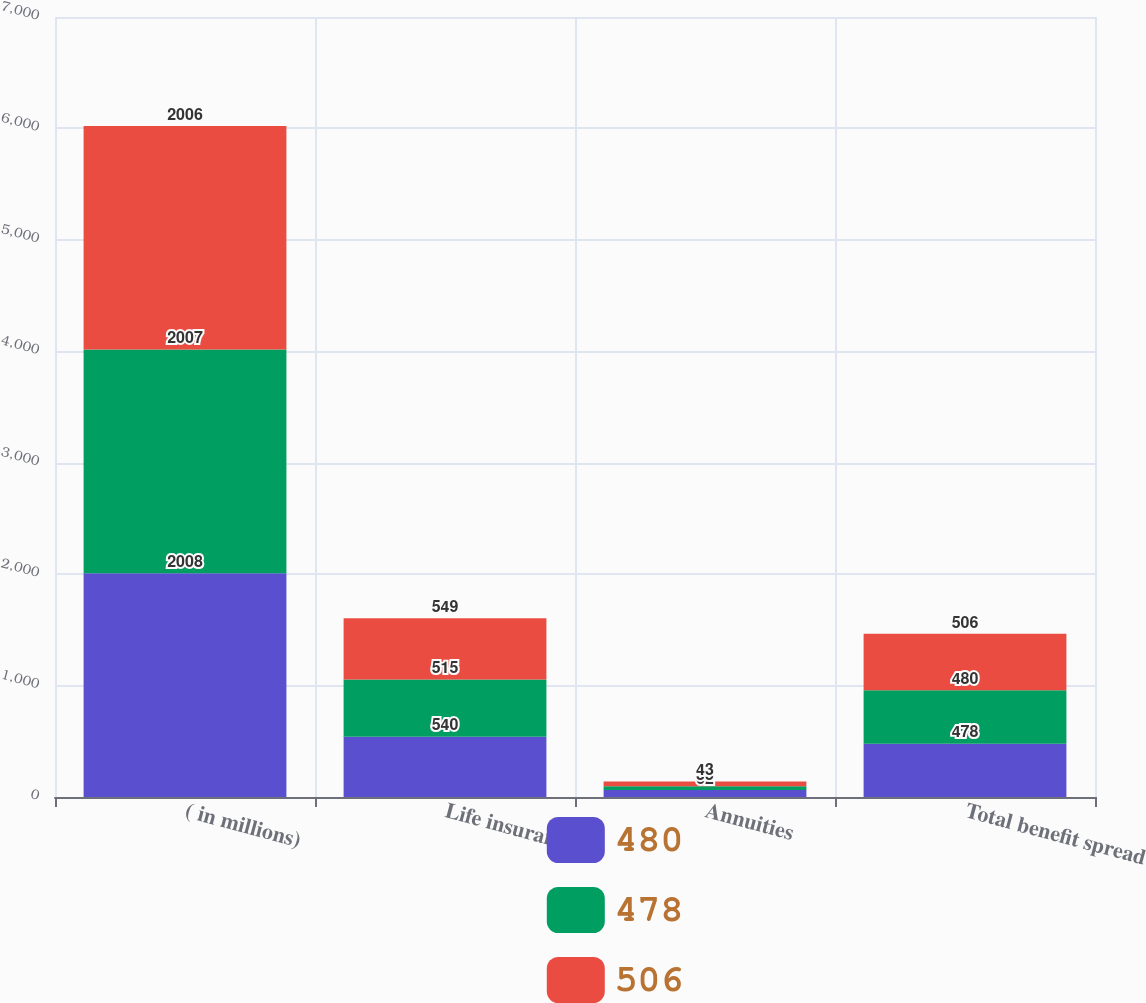Convert chart to OTSL. <chart><loc_0><loc_0><loc_500><loc_500><stacked_bar_chart><ecel><fcel>( in millions)<fcel>Life insurance<fcel>Annuities<fcel>Total benefit spread<nl><fcel>480<fcel>2008<fcel>540<fcel>62<fcel>478<nl><fcel>478<fcel>2007<fcel>515<fcel>35<fcel>480<nl><fcel>506<fcel>2006<fcel>549<fcel>43<fcel>506<nl></chart> 